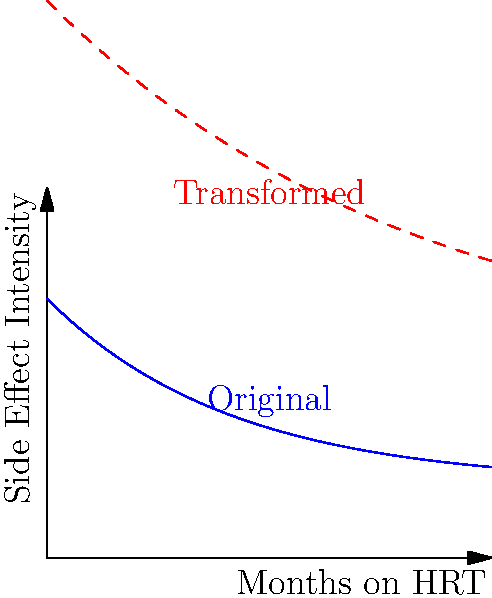A chart shows the intensity of a particular side effect over time for patients on Hormone Replacement Therapy (HRT). The blue curve represents the original data. The red dashed curve is obtained by applying multiple transformations to the blue curve. Which sequence of transformations correctly describes how to obtain the red curve from the blue curve?

1. Vertical stretch by a factor of 3, horizontal compression by a factor of 2, horizontal shift 2 units right, vertical shift 1 unit down
2. Vertical stretch by a factor of 3, horizontal stretch by a factor of 2, horizontal shift 2 units left, vertical shift 1 unit up
3. Vertical compression by a factor of 3, horizontal compression by a factor of 2, horizontal shift 2 units right, vertical shift 1 unit down
4. Vertical stretch by a factor of 3, horizontal compression by a factor of 2, horizontal shift 2 units left, vertical shift 1 unit down Let's analyze this step-by-step:

1) First, we need to understand the general form of transformations:
   $f(x) \rightarrow a \cdot f(b(x-h)) + k$
   where $a$ affects vertical stretch/compression, $b$ affects horizontal stretch/compression, $h$ affects horizontal shift, and $k$ affects vertical shift.

2) Looking at the red curve, we can see that:
   - It's taller than the blue curve, indicating a vertical stretch.
   - It's narrower than the blue curve, indicating a horizontal compression.
   - It's shifted slightly to the left compared to the blue curve.
   - It's shifted slightly downward compared to the blue curve.

3) Let's break down each transformation:
   - Vertical stretch: The red curve appears about 3 times taller, so $a = 3$.
   - Horizontal compression: The red curve is about half as wide, so $b = 2$.
   - Horizontal shift: The peak of the red curve is 2 units to the left, so $h = -2$.
   - Vertical shift: The red curve is 1 unit lower at its right end, so $k = -1$.

4) Putting this all together, the transformation can be written as:
   $g(x) = 3 \cdot f(2(x+2)) - 1$

5) This can be rewritten as:
   $g(x) = 3 \cdot f(2x+4) - 1$

6) Comparing this to the options given, we see that option 4 matches our analysis:
   Vertical stretch by a factor of 3, horizontal compression by a factor of 2, horizontal shift 2 units left, vertical shift 1 unit down.
Answer: 4. Vertical stretch by a factor of 3, horizontal compression by a factor of 2, horizontal shift 2 units left, vertical shift 1 unit down 